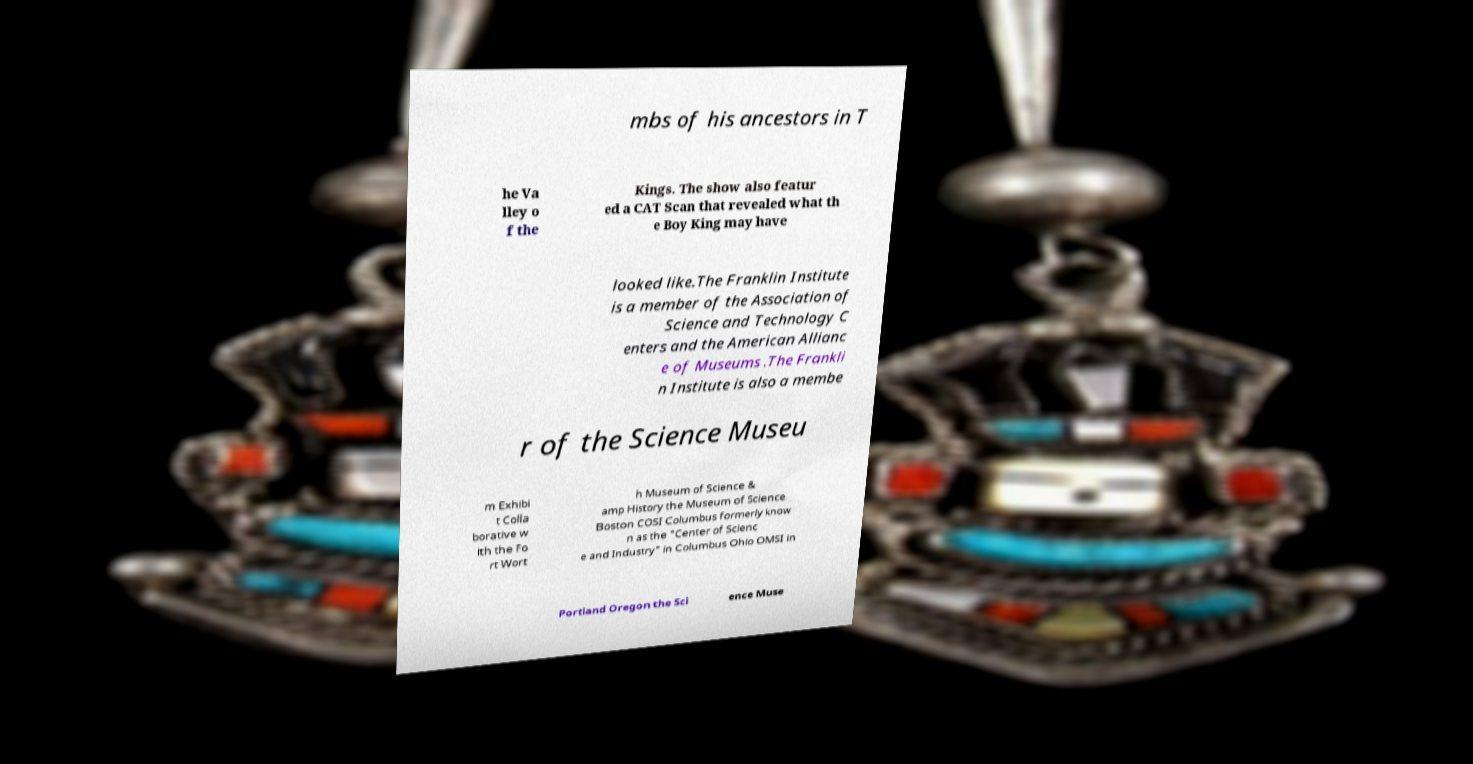Can you accurately transcribe the text from the provided image for me? mbs of his ancestors in T he Va lley o f the Kings. The show also featur ed a CAT Scan that revealed what th e Boy King may have looked like.The Franklin Institute is a member of the Association of Science and Technology C enters and the American Allianc e of Museums .The Frankli n Institute is also a membe r of the Science Museu m Exhibi t Colla borative w ith the Fo rt Wort h Museum of Science & amp History the Museum of Science Boston COSI Columbus formerly know n as the "Center of Scienc e and Industry" in Columbus Ohio OMSI in Portland Oregon the Sci ence Muse 